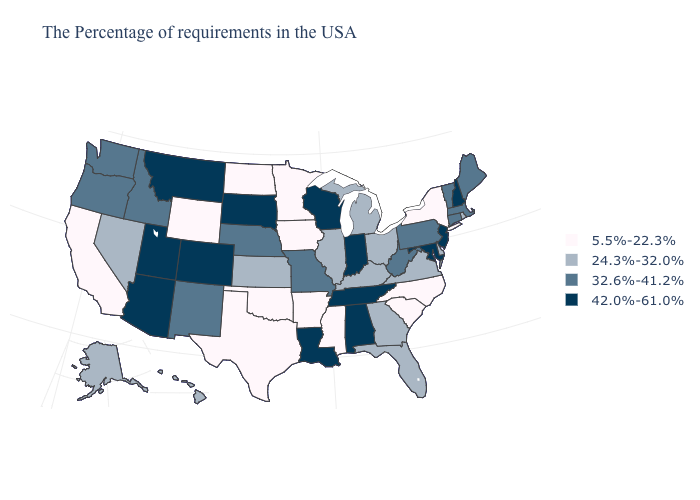What is the lowest value in the West?
Write a very short answer. 5.5%-22.3%. What is the value of Idaho?
Quick response, please. 32.6%-41.2%. Does the first symbol in the legend represent the smallest category?
Write a very short answer. Yes. Does New York have the lowest value in the Northeast?
Be succinct. Yes. Name the states that have a value in the range 24.3%-32.0%?
Answer briefly. Rhode Island, Delaware, Virginia, Ohio, Florida, Georgia, Michigan, Kentucky, Illinois, Kansas, Nevada, Alaska, Hawaii. What is the value of Alabama?
Quick response, please. 42.0%-61.0%. What is the lowest value in the USA?
Write a very short answer. 5.5%-22.3%. Which states have the lowest value in the West?
Concise answer only. Wyoming, California. What is the lowest value in the West?
Concise answer only. 5.5%-22.3%. Does Minnesota have the lowest value in the USA?
Concise answer only. Yes. What is the lowest value in the USA?
Write a very short answer. 5.5%-22.3%. Which states have the highest value in the USA?
Keep it brief. New Hampshire, New Jersey, Maryland, Indiana, Alabama, Tennessee, Wisconsin, Louisiana, South Dakota, Colorado, Utah, Montana, Arizona. Which states hav the highest value in the South?
Keep it brief. Maryland, Alabama, Tennessee, Louisiana. What is the value of Delaware?
Keep it brief. 24.3%-32.0%. Name the states that have a value in the range 32.6%-41.2%?
Keep it brief. Maine, Massachusetts, Vermont, Connecticut, Pennsylvania, West Virginia, Missouri, Nebraska, New Mexico, Idaho, Washington, Oregon. 